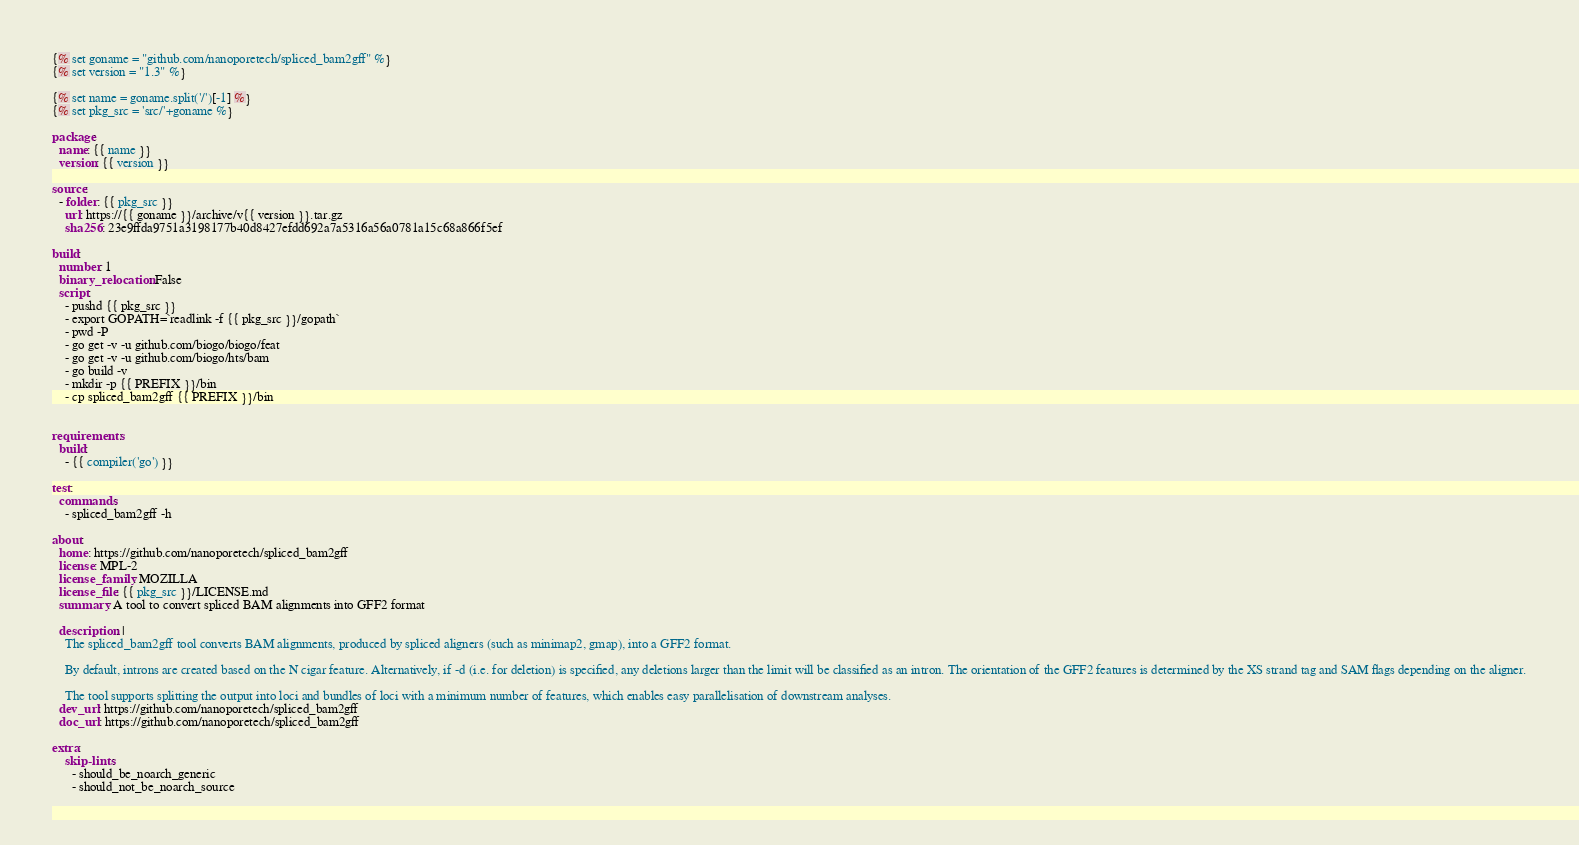<code> <loc_0><loc_0><loc_500><loc_500><_YAML_>{% set goname = "github.com/nanoporetech/spliced_bam2gff" %}
{% set version = "1.3" %}

{% set name = goname.split('/')[-1] %}
{% set pkg_src = 'src/'+goname %}

package:
  name: {{ name }}
  version: {{ version }}

source:
  - folder: {{ pkg_src }}
    url: https://{{ goname }}/archive/v{{ version }}.tar.gz
    sha256: 23e9ffda9751a3198177b40d8427efdd692a7a5316a56a0781a15c68a866f5ef

build:
  number: 1
  binary_relocation: False
  script:
    - pushd {{ pkg_src }}
    - export GOPATH=`readlink -f {{ pkg_src }}/gopath`
    - pwd -P
    - go get -v -u github.com/biogo/biogo/feat
    - go get -v -u github.com/biogo/hts/bam
    - go build -v
    - mkdir -p {{ PREFIX }}/bin
    - cp spliced_bam2gff {{ PREFIX }}/bin
    

requirements:
  build:
    - {{ compiler('go') }}

test:
  commands:
    - spliced_bam2gff -h

about:
  home: https://github.com/nanoporetech/spliced_bam2gff
  license: MPL-2
  license_family: MOZILLA
  license_file: {{ pkg_src }}/LICENSE.md
  summary: A tool to convert spliced BAM alignments into GFF2 format

  description: |
    The spliced_bam2gff tool converts BAM alignments, produced by spliced aligners (such as minimap2, gmap), into a GFF2 format.

    By default, introns are created based on the N cigar feature. Alternatively, if -d (i.e. for deletion) is specified, any deletions larger than the limit will be classified as an intron. The orientation of the GFF2 features is determined by the XS strand tag and SAM flags depending on the aligner.

    The tool supports splitting the output into loci and bundles of loci with a minimum number of features, which enables easy parallelisation of downstream analyses. 
  dev_url: https://github.com/nanoporetech/spliced_bam2gff
  doc_url: https://github.com/nanoporetech/spliced_bam2gff

extra:
    skip-lints:
      - should_be_noarch_generic
      - should_not_be_noarch_source

</code> 